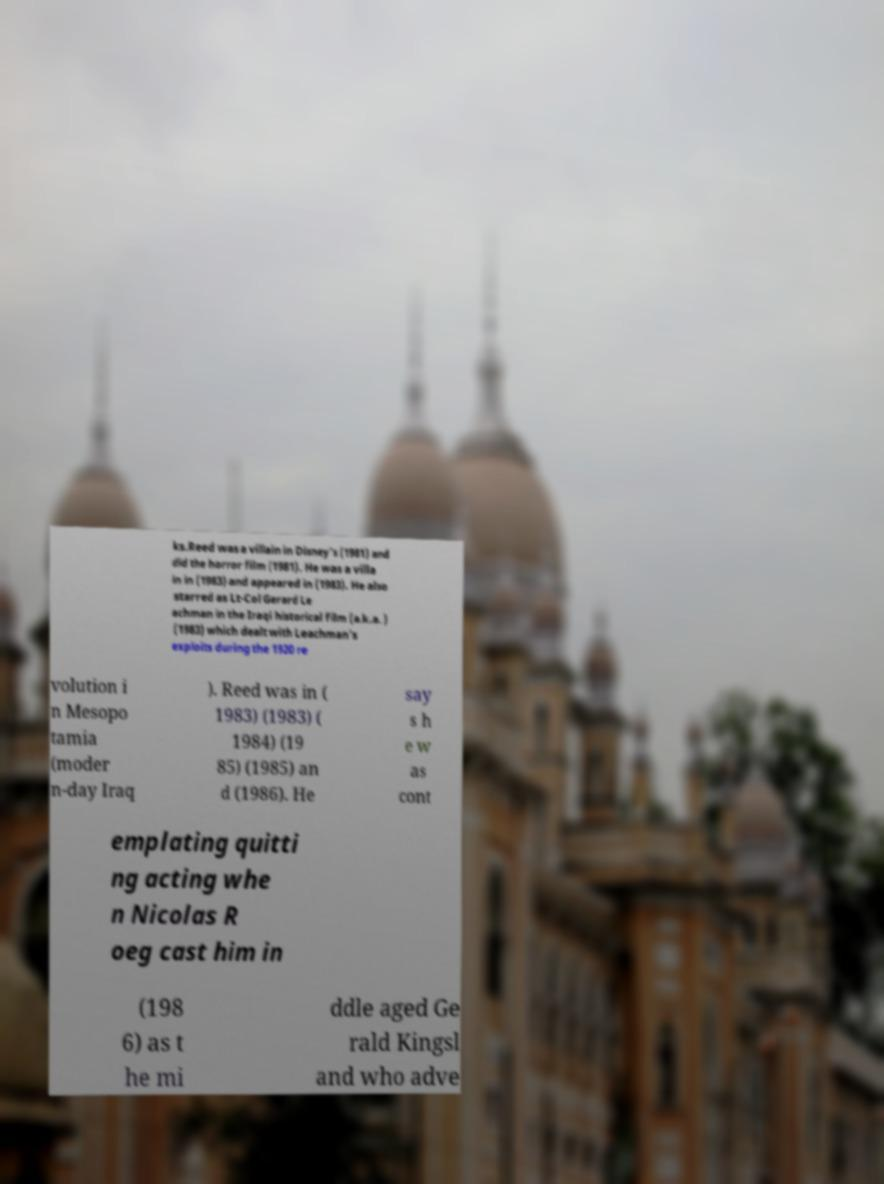Please identify and transcribe the text found in this image. ks.Reed was a villain in Disney's (1981) and did the horror film (1981). He was a villa in in (1983) and appeared in (1983). He also starred as Lt-Col Gerard Le achman in the Iraqi historical film (a.k.a. ) (1983) which dealt with Leachman's exploits during the 1920 re volution i n Mesopo tamia (moder n-day Iraq ). Reed was in ( 1983) (1983) ( 1984) (19 85) (1985) an d (1986). He say s h e w as cont emplating quitti ng acting whe n Nicolas R oeg cast him in (198 6) as t he mi ddle aged Ge rald Kingsl and who adve 